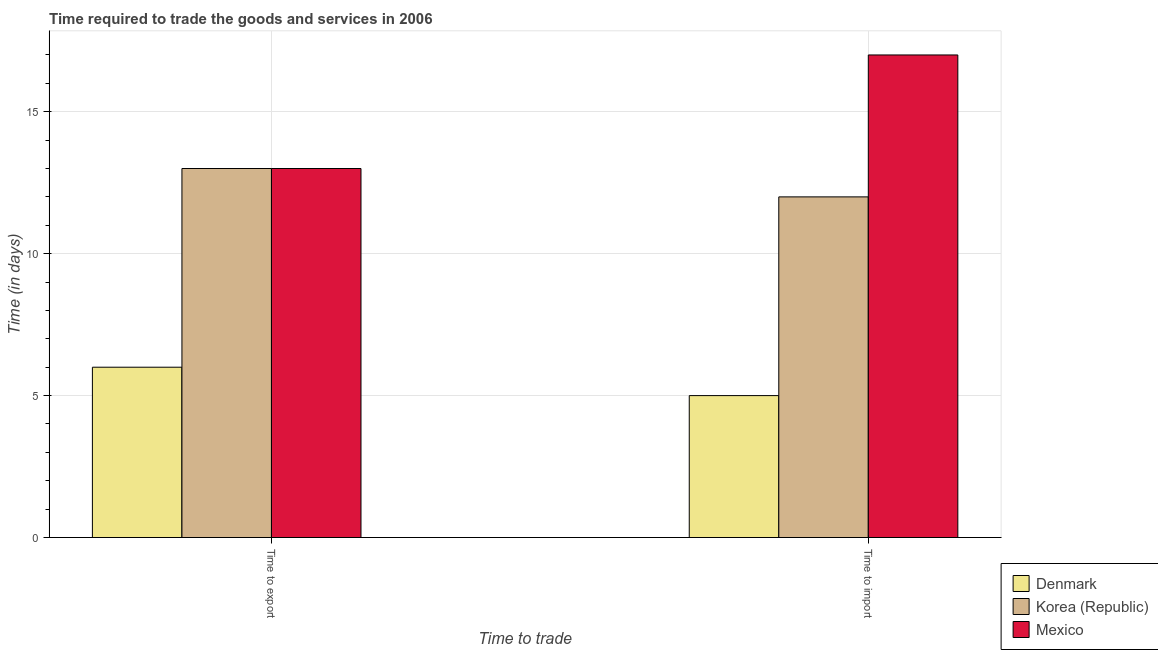How many different coloured bars are there?
Keep it short and to the point. 3. How many groups of bars are there?
Your answer should be compact. 2. Are the number of bars on each tick of the X-axis equal?
Provide a succinct answer. Yes. What is the label of the 1st group of bars from the left?
Make the answer very short. Time to export. What is the time to import in Mexico?
Offer a very short reply. 17. Across all countries, what is the maximum time to import?
Your answer should be very brief. 17. What is the total time to export in the graph?
Your answer should be compact. 32. What is the difference between the time to import in Denmark and that in Mexico?
Keep it short and to the point. -12. What is the difference between the time to export in Mexico and the time to import in Korea (Republic)?
Give a very brief answer. 1. What is the average time to export per country?
Provide a short and direct response. 10.67. What is the difference between the time to import and time to export in Denmark?
Your response must be concise. -1. What is the ratio of the time to import in Denmark to that in Korea (Republic)?
Give a very brief answer. 0.42. In how many countries, is the time to export greater than the average time to export taken over all countries?
Keep it short and to the point. 2. What does the 3rd bar from the left in Time to import represents?
Your answer should be compact. Mexico. What does the 3rd bar from the right in Time to import represents?
Provide a short and direct response. Denmark. Are all the bars in the graph horizontal?
Ensure brevity in your answer.  No. How many countries are there in the graph?
Offer a very short reply. 3. What is the difference between two consecutive major ticks on the Y-axis?
Provide a short and direct response. 5. How are the legend labels stacked?
Your answer should be very brief. Vertical. What is the title of the graph?
Ensure brevity in your answer.  Time required to trade the goods and services in 2006. What is the label or title of the X-axis?
Ensure brevity in your answer.  Time to trade. What is the label or title of the Y-axis?
Provide a succinct answer. Time (in days). What is the Time (in days) of Denmark in Time to export?
Your answer should be compact. 6. What is the Time (in days) of Mexico in Time to export?
Your answer should be compact. 13. What is the Time (in days) of Denmark in Time to import?
Ensure brevity in your answer.  5. What is the Time (in days) in Mexico in Time to import?
Give a very brief answer. 17. Across all Time to trade, what is the maximum Time (in days) of Mexico?
Make the answer very short. 17. What is the total Time (in days) in Mexico in the graph?
Your response must be concise. 30. What is the difference between the Time (in days) of Denmark in Time to export and that in Time to import?
Provide a succinct answer. 1. What is the difference between the Time (in days) of Korea (Republic) in Time to export and that in Time to import?
Give a very brief answer. 1. What is the difference between the Time (in days) of Denmark in Time to export and the Time (in days) of Korea (Republic) in Time to import?
Provide a succinct answer. -6. What is the average Time (in days) of Korea (Republic) per Time to trade?
Your answer should be compact. 12.5. What is the average Time (in days) in Mexico per Time to trade?
Your response must be concise. 15. What is the difference between the Time (in days) of Denmark and Time (in days) of Korea (Republic) in Time to export?
Offer a terse response. -7. What is the difference between the Time (in days) in Denmark and Time (in days) in Mexico in Time to export?
Ensure brevity in your answer.  -7. What is the difference between the Time (in days) in Korea (Republic) and Time (in days) in Mexico in Time to export?
Provide a succinct answer. 0. What is the ratio of the Time (in days) of Denmark in Time to export to that in Time to import?
Provide a succinct answer. 1.2. What is the ratio of the Time (in days) of Korea (Republic) in Time to export to that in Time to import?
Give a very brief answer. 1.08. What is the ratio of the Time (in days) of Mexico in Time to export to that in Time to import?
Give a very brief answer. 0.76. What is the difference between the highest and the second highest Time (in days) of Korea (Republic)?
Keep it short and to the point. 1. What is the difference between the highest and the second highest Time (in days) of Mexico?
Offer a very short reply. 4. What is the difference between the highest and the lowest Time (in days) in Denmark?
Offer a terse response. 1. 